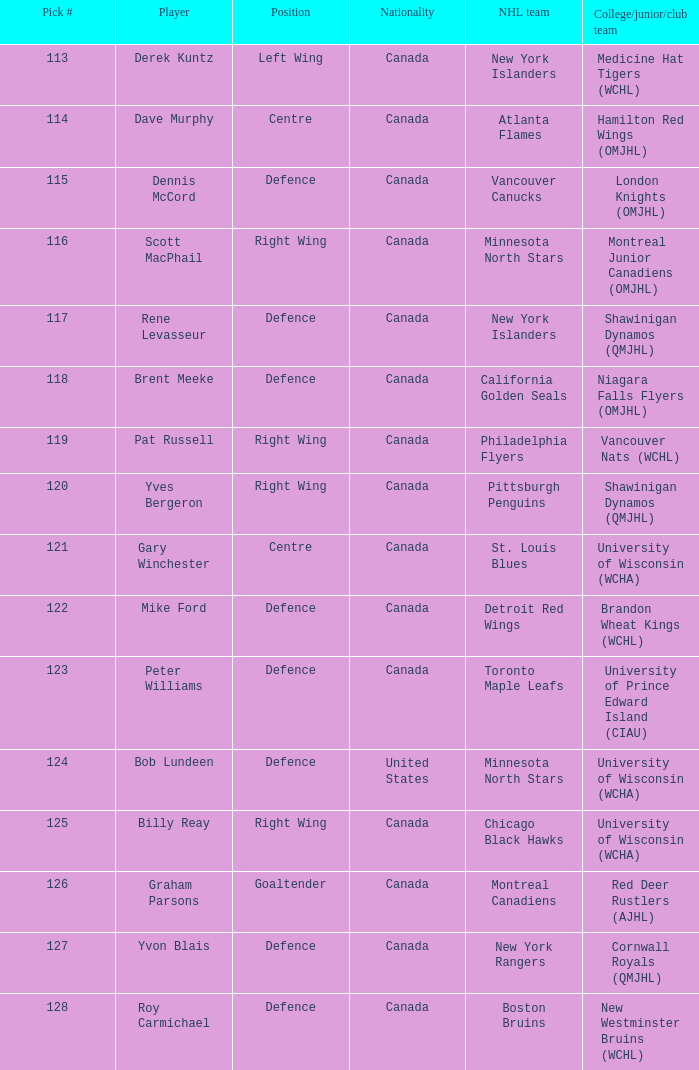What is the title for choice number 128? Defence. 